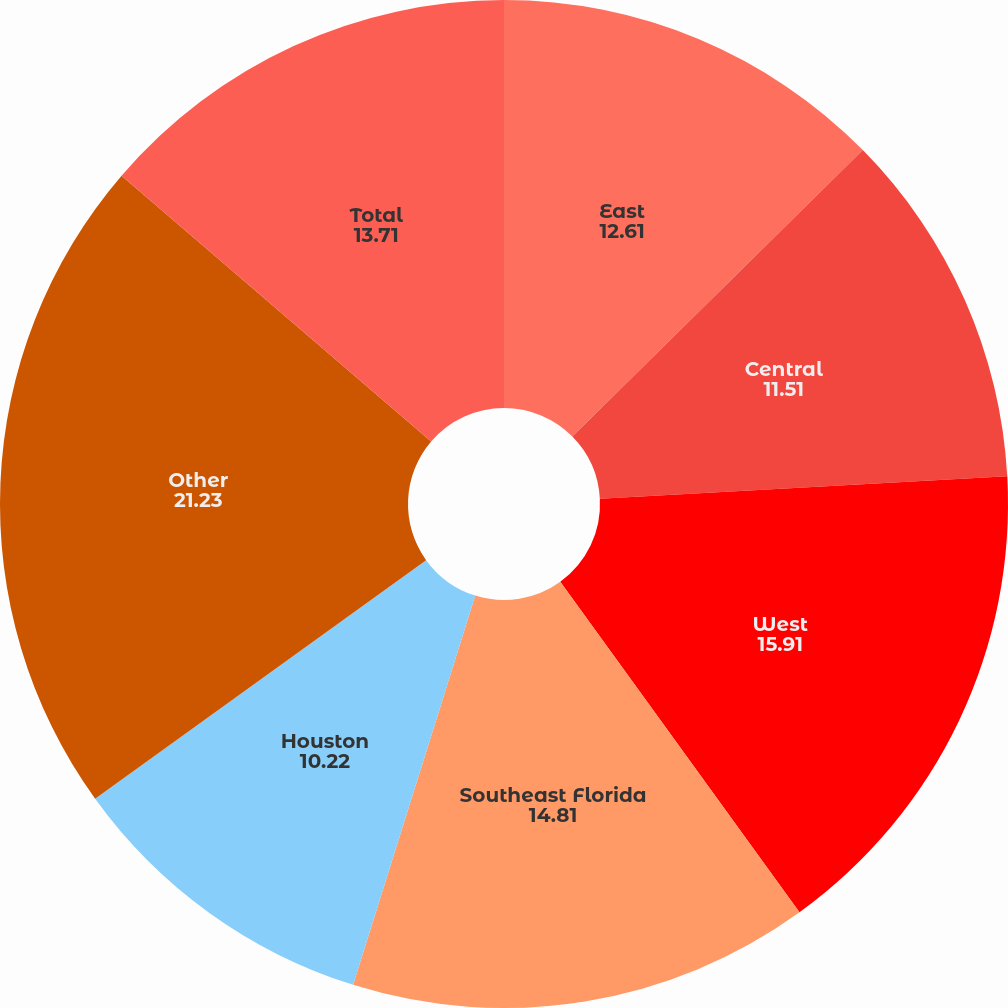Convert chart to OTSL. <chart><loc_0><loc_0><loc_500><loc_500><pie_chart><fcel>East<fcel>Central<fcel>West<fcel>Southeast Florida<fcel>Houston<fcel>Other<fcel>Total<nl><fcel>12.61%<fcel>11.51%<fcel>15.91%<fcel>14.81%<fcel>10.22%<fcel>21.23%<fcel>13.71%<nl></chart> 